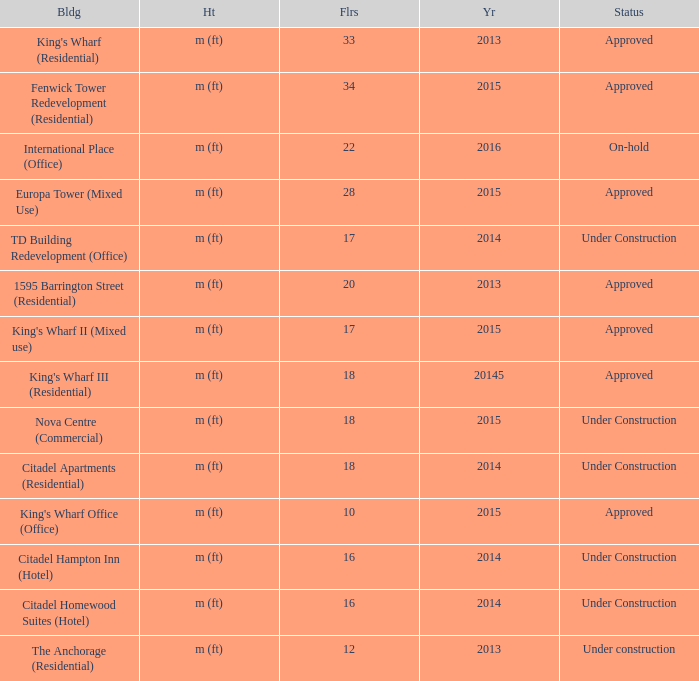What is the status of the building with more than 28 floor and a year of 2013? Approved. 